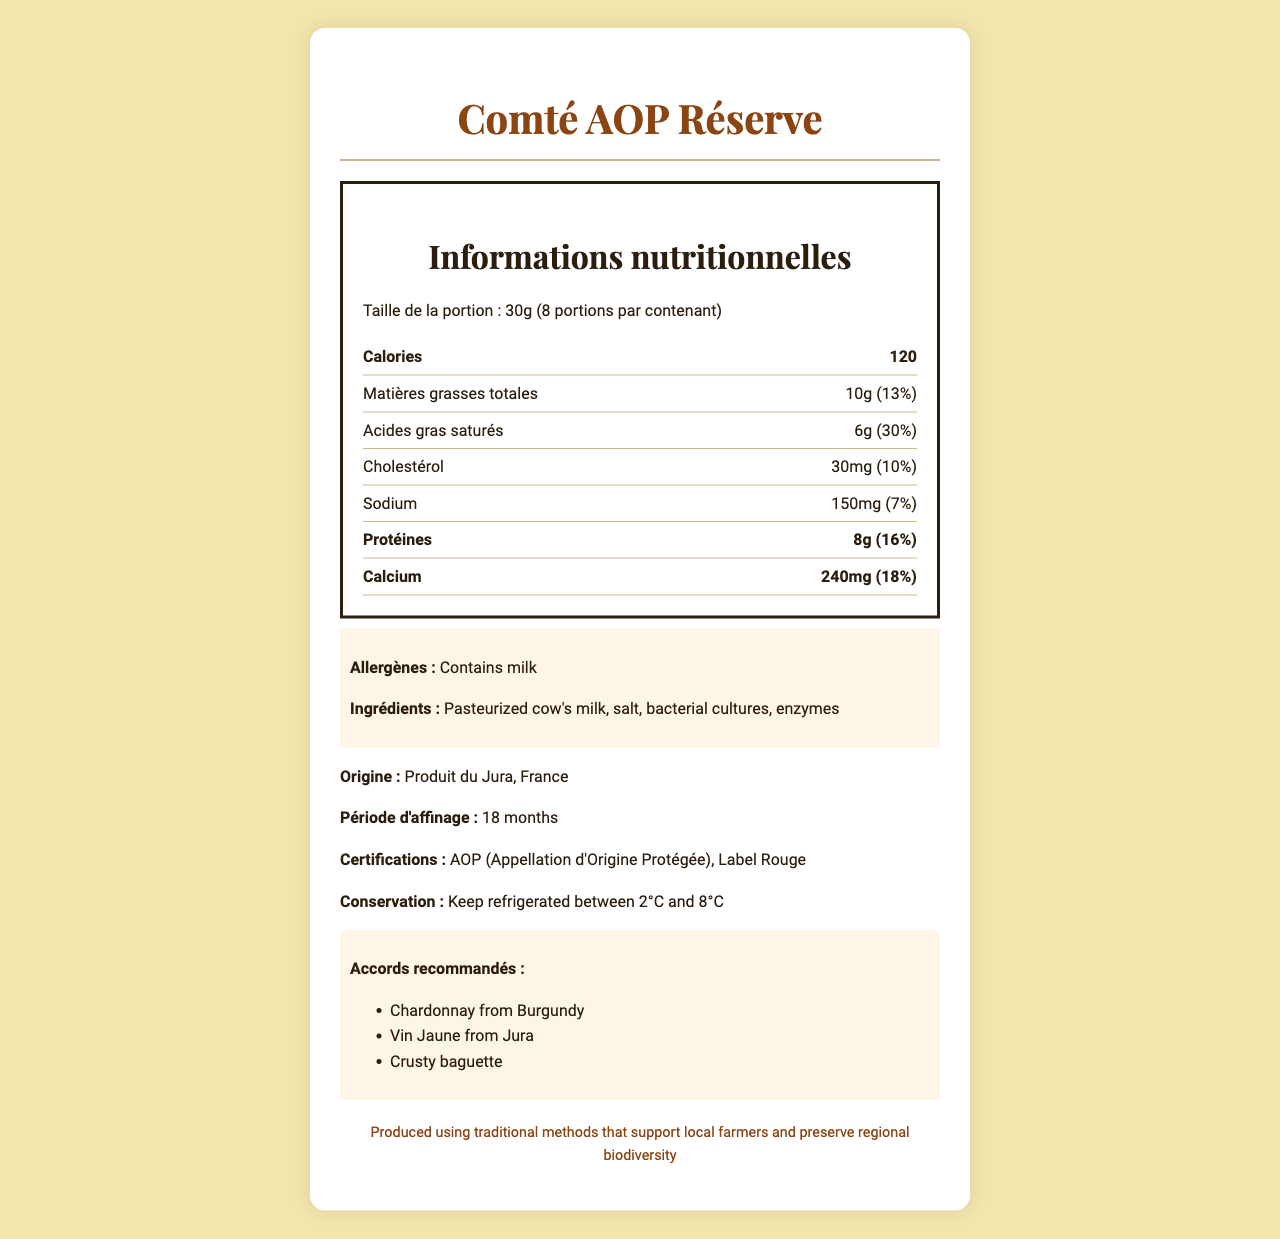what is the serving size of Comté AOP Réserve? The serving size is mentioned as "30g" in the document.
Answer: 30g how many calories are in each serving of the cheese? The calories per serving are given as 120 in the document.
Answer: 120 calories what is the total fat content per serving? The total fat per serving is listed as 10g.
Answer: 10g what is the calcium percentage of the daily value per serving? The calcium percentage of the daily value per serving is indicated as 18%.
Answer: 18% name one wine that pairs well with Comté AOP Réserve One of the pairing recommendations listed is "Chardonnay from Burgundy".
Answer: Chardonnay from Burgundy which of the following is true regarding the allergens? A. Contains nuts B. Contains milk C. Contains gluten The document mentions that the cheese contains milk as an allergen.
Answer: B how much protein is there in a single serving? The amount of protein in a single serving is 8g.
Answer: 8g what are the ingredients listed for Comté AOP Réserve? The ingredients are listed clearly in the document.
Answer: Pasteurized cow's milk, salt, bacterial cultures, enzymes what certifications does the cheese have? A. AOP B. Label Rouge C. AOP and Label Rouge The document specifies that the cheese has both AOP and Label Rouge certifications.
Answer: C is there any trans fat in the cheese? The document specifies that there are 0g of trans fat in the cheese.
Answer: No summarize the main idea of the document The summary covers the key points like nutritional information, allergen information, ingredients, origin, pairing recommendations, and certifications.
Answer: The document provides detailed nutritional information about Comté AOP Réserve cheese, including its serving size, calorie count, fat and protein content, and calcium levels. It also includes allergen information, ingredients, origin, pairing recommendations, and certifications. what is the total carbohydrate content per serving? The total carbohydrate content per serving is listed as 0g.
Answer: 0g how much sodium is there per serving? The sodium content per serving is given as 150mg.
Answer: 150mg why is there no information about fiber content in the document? The document does not provide details about dietary fiber, so the answer cannot be determined.
Answer: Not enough information what is the origin of Comté AOP Réserve? The origin statement in the document says "Produit du Jura, France".
Answer: Produit du Jura, France 